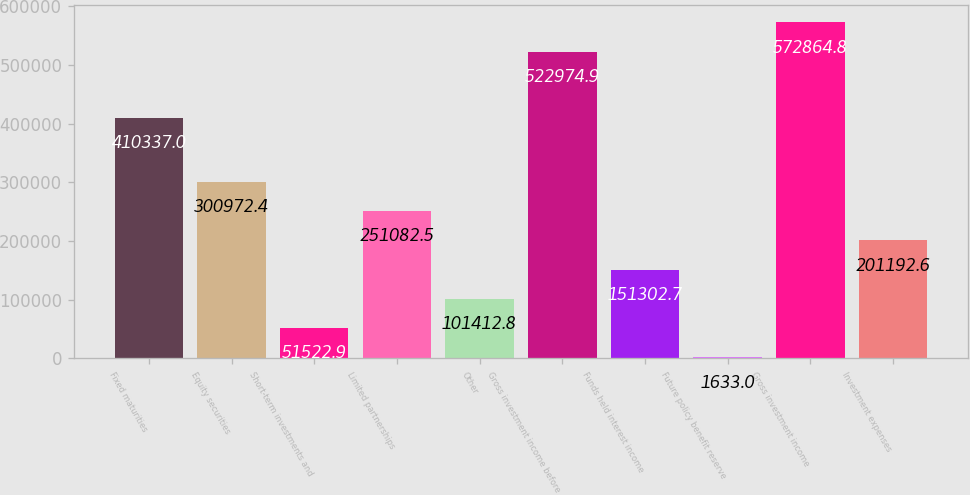Convert chart to OTSL. <chart><loc_0><loc_0><loc_500><loc_500><bar_chart><fcel>Fixed maturities<fcel>Equity securities<fcel>Short-term investments and<fcel>Limited partnerships<fcel>Other<fcel>Gross investment income before<fcel>Funds held interest income<fcel>Future policy benefit reserve<fcel>Gross investment income<fcel>Investment expenses<nl><fcel>410337<fcel>300972<fcel>51522.9<fcel>251082<fcel>101413<fcel>522975<fcel>151303<fcel>1633<fcel>572865<fcel>201193<nl></chart> 